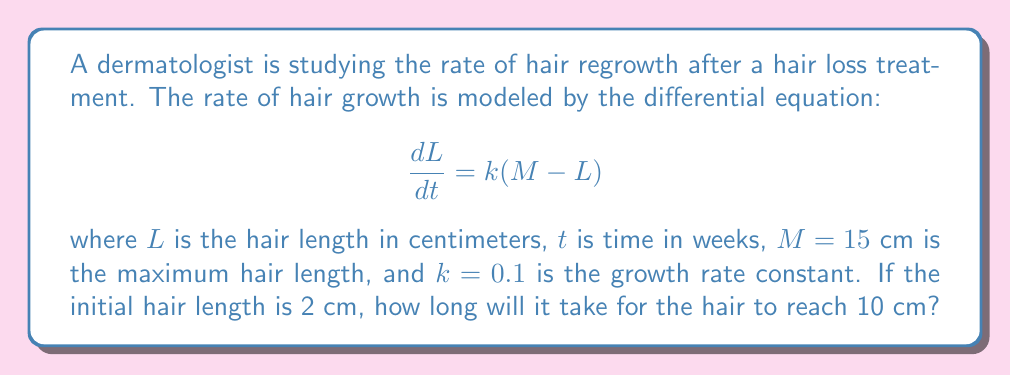Solve this math problem. To solve this problem, we need to use the given differential equation and initial condition:

1) The differential equation is:
   $$\frac{dL}{dt} = k(M - L)$$

2) Separate variables:
   $$\frac{dL}{M - L} = k dt$$

3) Integrate both sides:
   $$\int \frac{dL}{M - L} = \int k dt$$

4) Solve the integral:
   $$-\ln|M - L| = kt + C$$

5) Apply the initial condition: At $t = 0$, $L = 2$ cm
   $$-\ln|15 - 2| = 0 + C$$
   $$C = -\ln(13)$$

6) Substitute back into the general solution:
   $$-\ln|M - L| = kt - \ln(13)$$

7) Simplify:
   $$\ln|\frac{M - L}{13}| = -kt$$

8) Exponentiate both sides:
   $$\frac{M - L}{13} = e^{-kt}$$

9) Solve for $L$:
   $$L = M - 13e^{-kt}$$

10) We want to find $t$ when $L = 10$ cm:
    $$10 = 15 - 13e^{-0.1t}$$

11) Solve for $t$:
    $$13e^{-0.1t} = 5$$
    $$e^{-0.1t} = \frac{5}{13}$$
    $$-0.1t = \ln(\frac{5}{13})$$
    $$t = -10\ln(\frac{5}{13}) \approx 9.56$$

Therefore, it will take approximately 9.56 weeks for the hair to reach 10 cm.
Answer: 9.56 weeks 